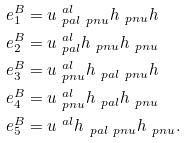<formula> <loc_0><loc_0><loc_500><loc_500>e ^ { B } _ { 1 } & = u ^ { \ a l } _ { \ p a l \ p n u } h _ { \ p n u } h \\ e ^ { B } _ { 2 } & = u ^ { \ a l } _ { \ p a l } h _ { \ p n u } h _ { \ p n u } \\ e ^ { B } _ { 3 } & = u ^ { \ a l } _ { \ p n u } h _ { \ p a l \ p n u } h \\ e ^ { B } _ { 4 } & = u ^ { \ a l } _ { \ p n u } h _ { \ p a l } h _ { \ p n u } \\ e ^ { B } _ { 5 } & = u ^ { \ a l } h _ { \ p a l \ p n u } h _ { \ p n u } .</formula> 